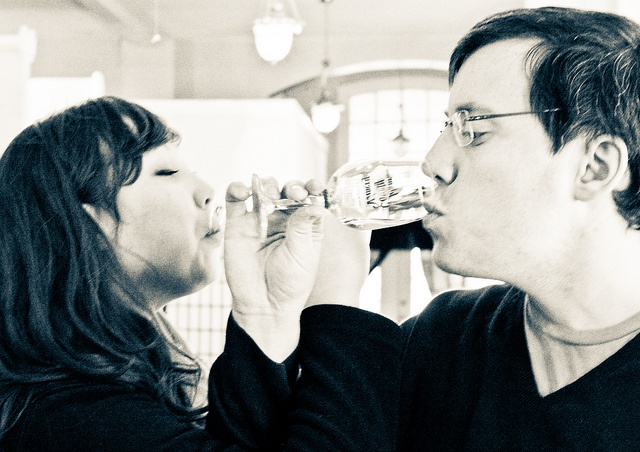Describe the objects in this image and their specific colors. I can see people in lightgray, black, ivory, darkgray, and gray tones, people in lightgray, black, blue, and darkblue tones, wine glass in lightgray, white, darkgray, and gray tones, and wine glass in lightgray, ivory, darkgray, and gray tones in this image. 